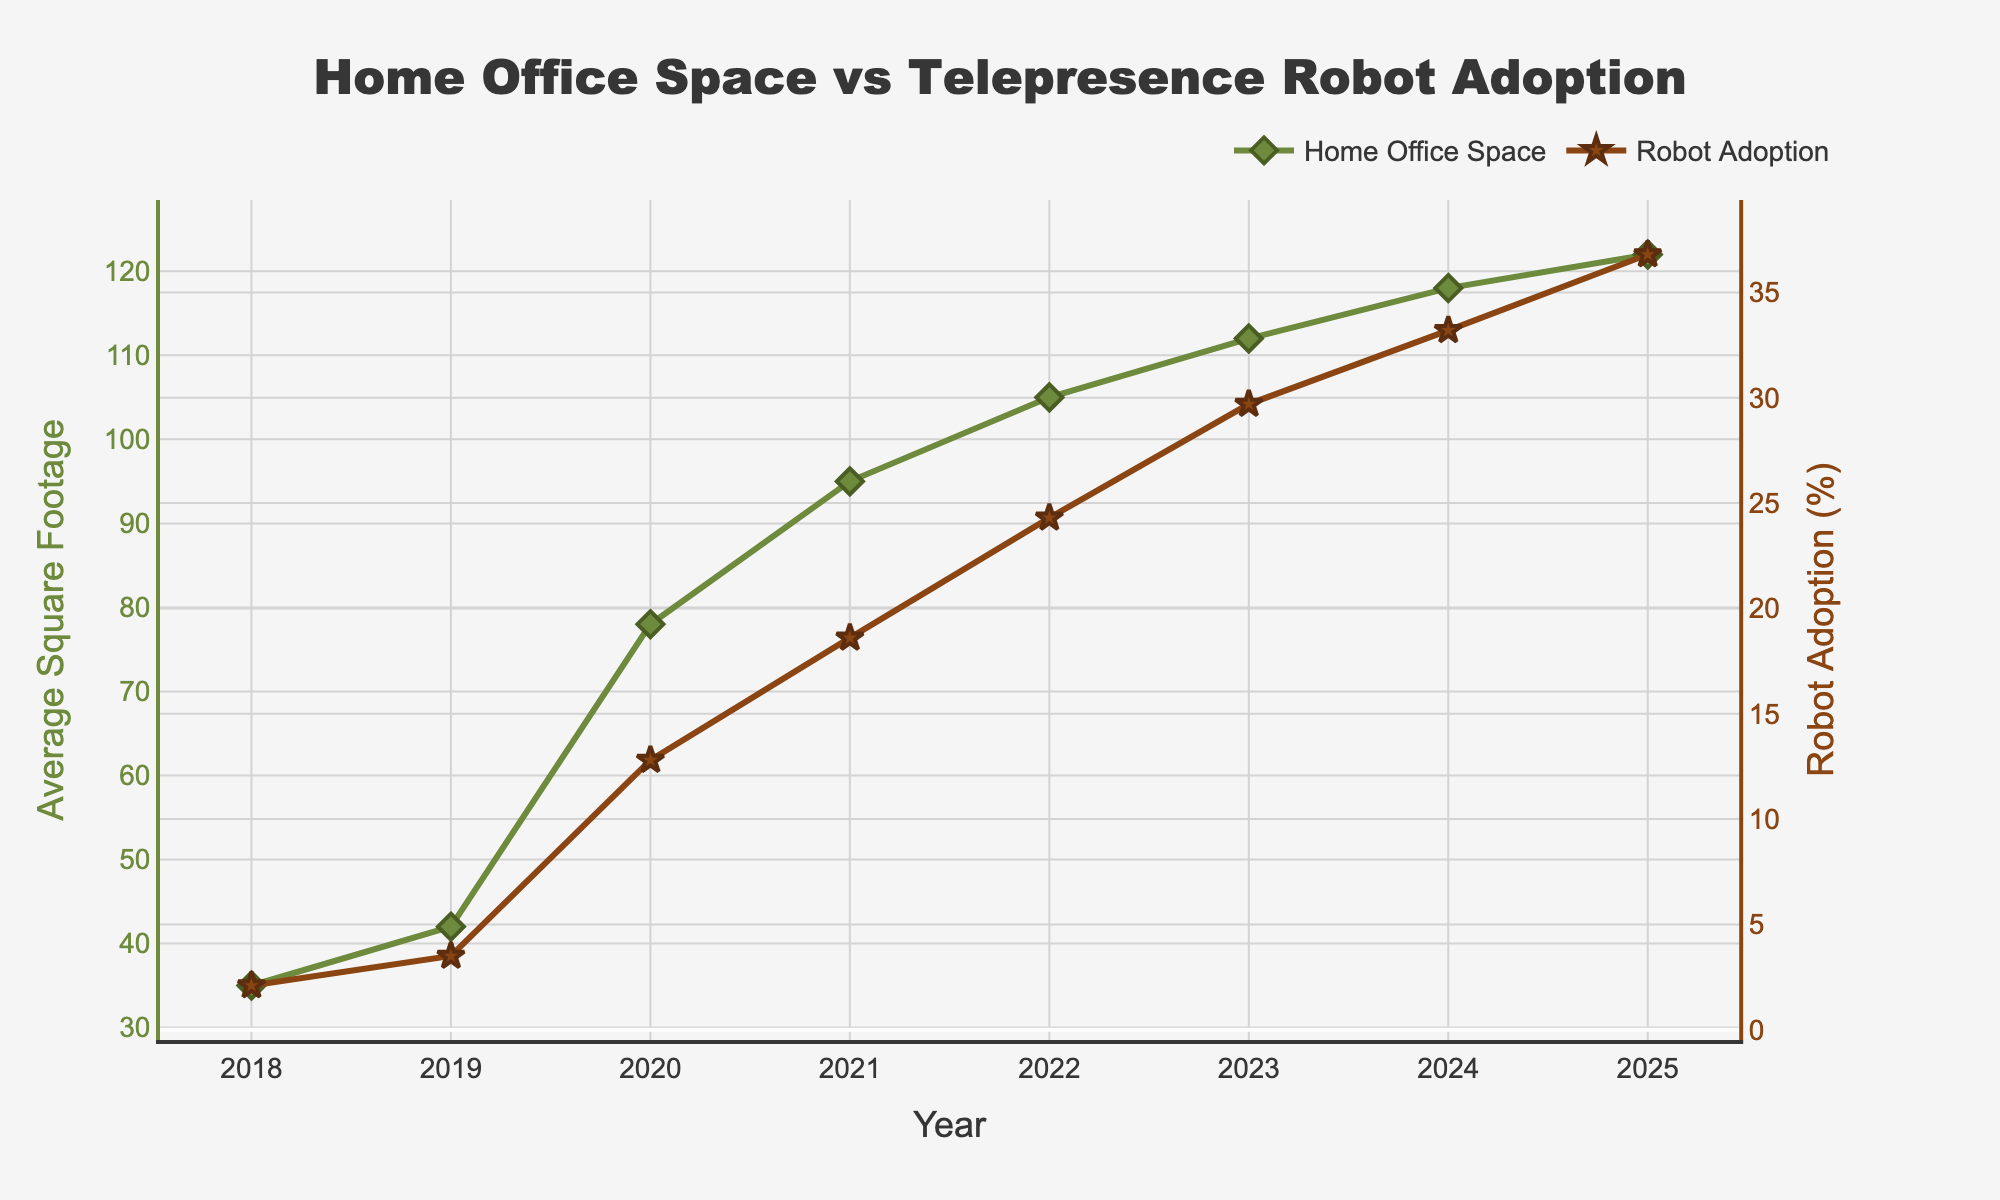What is the average square footage dedicated to home offices in 2021? Look for the data point corresponding to the year 2021 in the chart and find the value on the left Y-axis, which represents the average square footage for home offices. The value for 2021 is 95.
Answer: 95 How much did telepresence robot adoption increase between 2018 and 2020? Identify the telepresence robot adoption percentages for the years 2018 and 2020 from the chart. Subtract the 2018 value (2.1%) from the 2020 value (12.8%) to find the increase. 12.8 - 2.1 = 10.7
Answer: 10.7 Which year shows the highest average square footage dedicated to home offices, and what is the value? From the chart, identify the year with the tallest point on the green line representing the average square footage. The highest value is in 2025, at 122 square feet.
Answer: 2025, 122 Compare the rate of increase in average square footage for home offices between 2019 to 2020 and 2020 to 2021. Which period had a higher rate of increase? Calculate the difference for both periods: For 2019-2020: 78 - 42 = 36. For 2020-2021: 95 - 78 = 17. The period 2019-2020 had an increase of 36 square feet, while 2020-2021 had an increase of 17 square feet. Compare these two differences; 36 is greater than 17, so 2019-2020 had a higher rate of increase.
Answer: 2019-2020 What is the correlation between average square footage dedicated to home offices and telepresence robot adoption from 2018 to 2025? By examining the overall trend in the chart, observe that both metrics increase over the years. This suggests a positive correlation; as telepresence robot adoption rises, the average square footage dedicated to home offices also increases.
Answer: Positive correlation In which year did the average square footage for home offices and telepresence robot adoption both show a sharp increase? By looking at the graph, you see that between 2019 and 2020, there were notable jumps in both metrics — from 42 to 78 square feet for home offices and from 3.5% to 12.8% for robot adoption.
Answer: 2019-2020 Calculate the combined percentage increase in telepresence robot adoption from 2018 to 2025. Calculate the initial and final values, then use the formula for percentage increase: ((Final - Initial) / Initial) * 100. For telepresence robot adoption: ((36.8 - 2.1) / 2.1) * 100. First find the difference: 36.8 - 2.1 = 34.7. Then, (34.7 / 2.1) * 100 ≈ 1652.38%.
Answer: 1652.38% Between which two consecutive years did the average square footage for home offices increase by the smallest amount? Calculate the increase between each pair of consecutive years: - 2018-2019: 42 - 35 = 7 - 2019-2020: 78 - 42 = 36 - 2020-2021: 95 - 78 = 17 - 2021-2022: 105 - 95 = 10 - 2022-2023: 112 - 105 = 7 - 2023-2024: 118 - 112 = 6 - 2024-2025: 122 - 118 = 4. The smallest increase is between 2024 and 2025 (4 square feet).
Answer: 2024-2025 